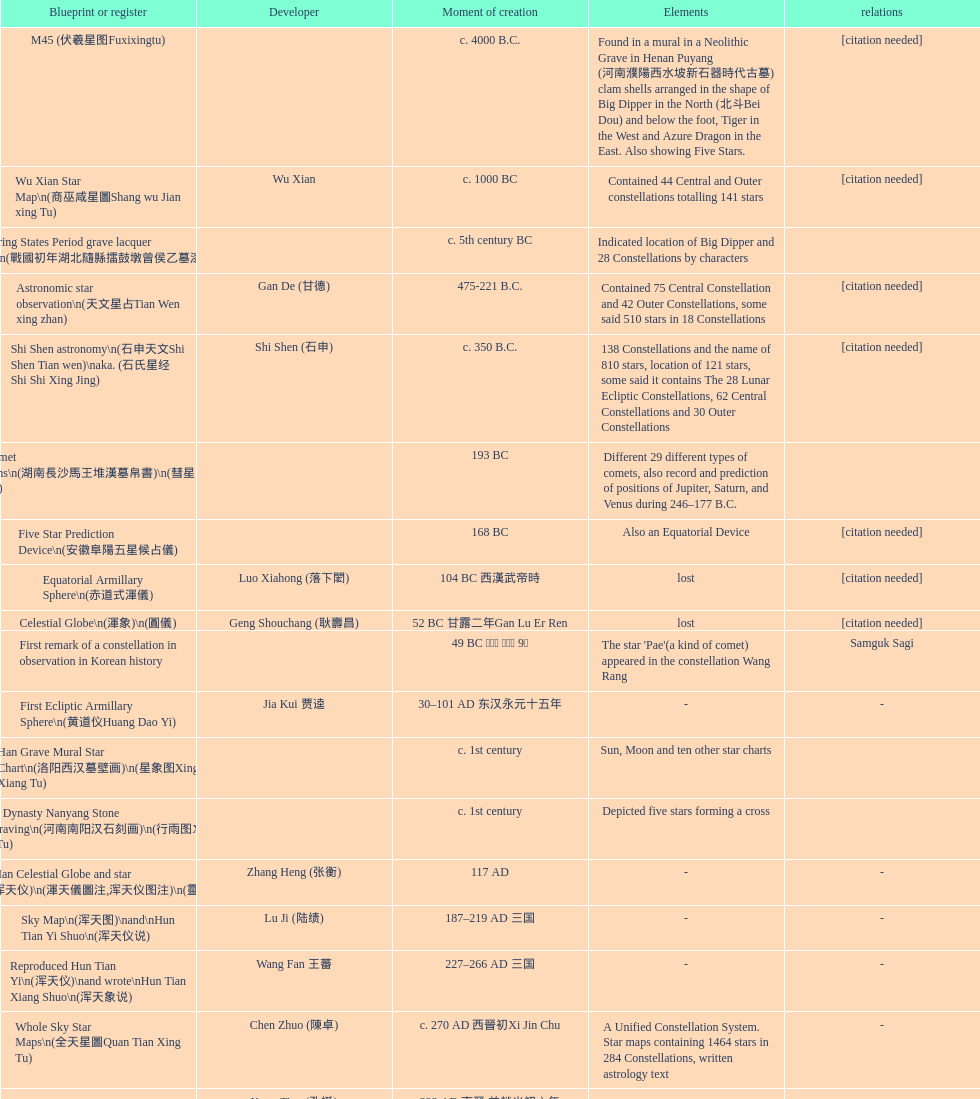Regarding the creation of chinese star maps, which one is known as the first? M45 (伏羲星图Fuxixingtu). 